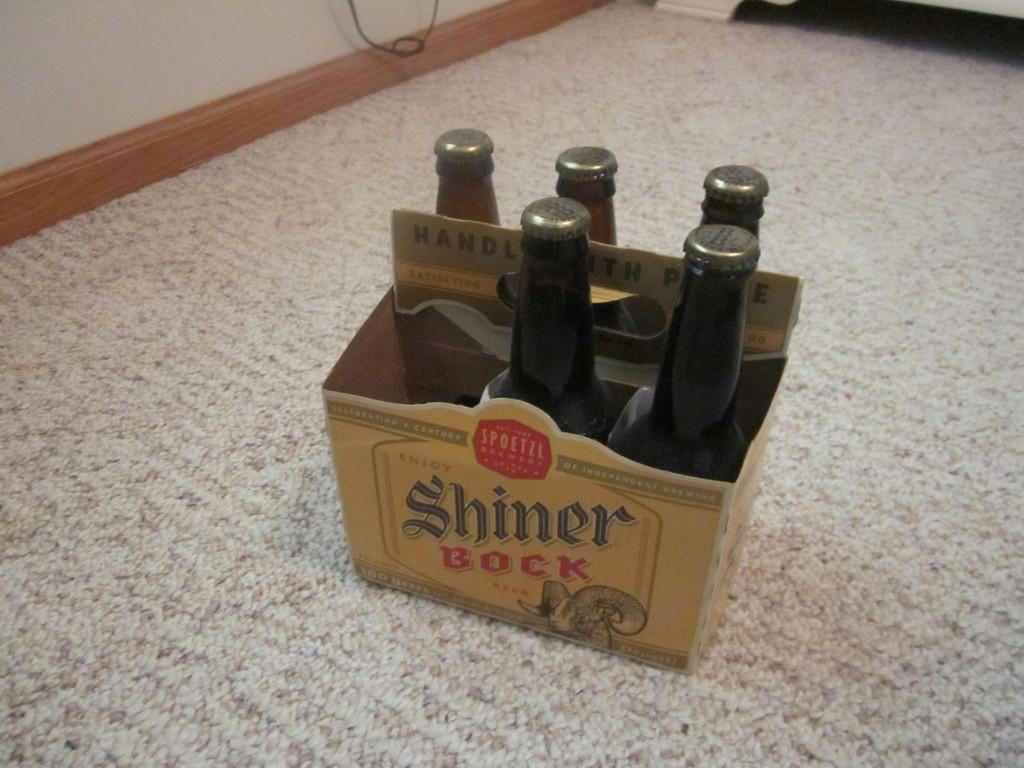<image>
Offer a succinct explanation of the picture presented. A six pack of Shiner Bock beer appears to have one bottle missing. 